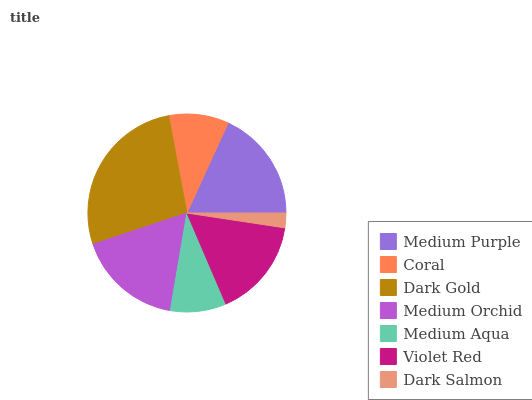Is Dark Salmon the minimum?
Answer yes or no. Yes. Is Dark Gold the maximum?
Answer yes or no. Yes. Is Coral the minimum?
Answer yes or no. No. Is Coral the maximum?
Answer yes or no. No. Is Medium Purple greater than Coral?
Answer yes or no. Yes. Is Coral less than Medium Purple?
Answer yes or no. Yes. Is Coral greater than Medium Purple?
Answer yes or no. No. Is Medium Purple less than Coral?
Answer yes or no. No. Is Violet Red the high median?
Answer yes or no. Yes. Is Violet Red the low median?
Answer yes or no. Yes. Is Medium Orchid the high median?
Answer yes or no. No. Is Coral the low median?
Answer yes or no. No. 